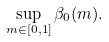<formula> <loc_0><loc_0><loc_500><loc_500>\sup _ { m \in [ 0 , 1 ] } \beta _ { 0 } ( m ) .</formula> 